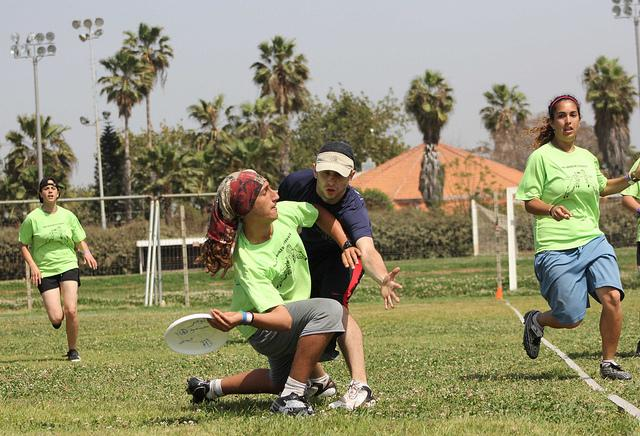The players are wearing the same shirts because they play in a what?

Choices:
A) family reunion
B) league
C) school
D) random match league 